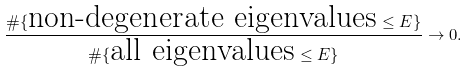Convert formula to latex. <formula><loc_0><loc_0><loc_500><loc_500>\frac { \# \{ \text {non-degenerate eigenvalues} \leq E \} } { \# \{ \text {all eigenvalues} \leq E \} } \to 0 .</formula> 